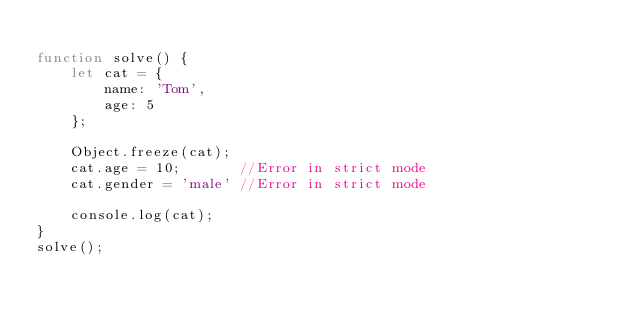Convert code to text. <code><loc_0><loc_0><loc_500><loc_500><_JavaScript_>
function solve() {
    let cat = {
        name: 'Tom',
        age: 5
    };

    Object.freeze(cat);
    cat.age = 10;       //Error in strict mode 
    cat.gender = 'male' //Error in strict mode

    console.log(cat);
}
solve();</code> 